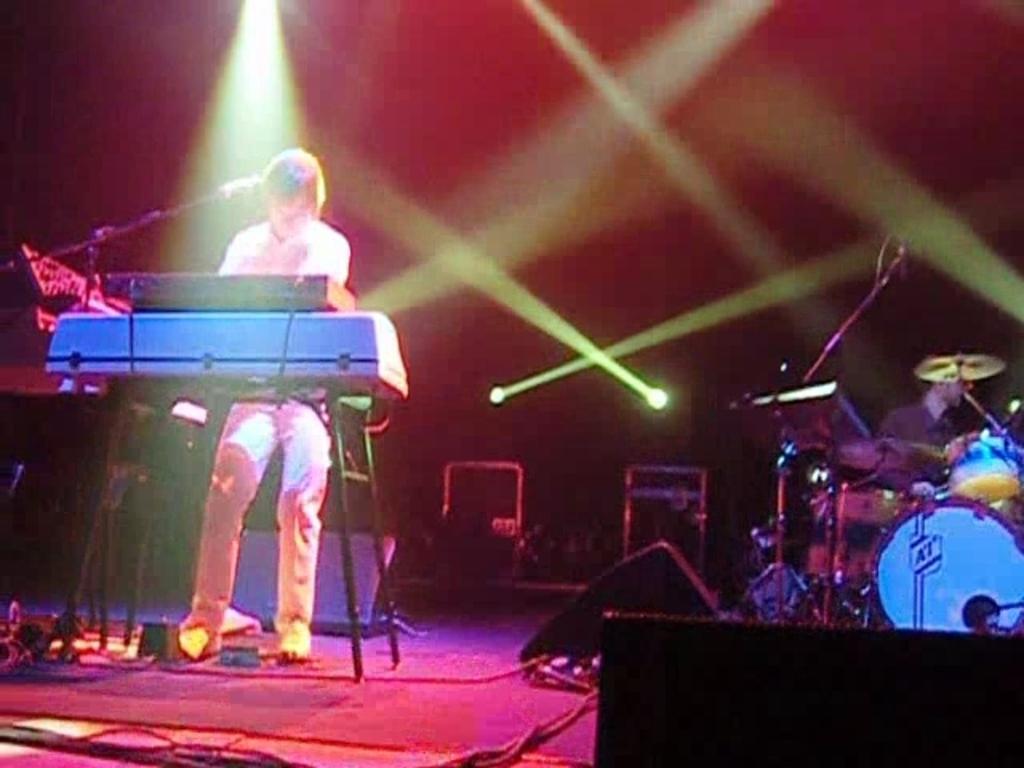Please provide a concise description of this image. In this image we can see a person standing on the stage playing piano there is microphone in front of him, on right side of the image there is a person sitting on a chair beating drums and in the background we can see some lights. 